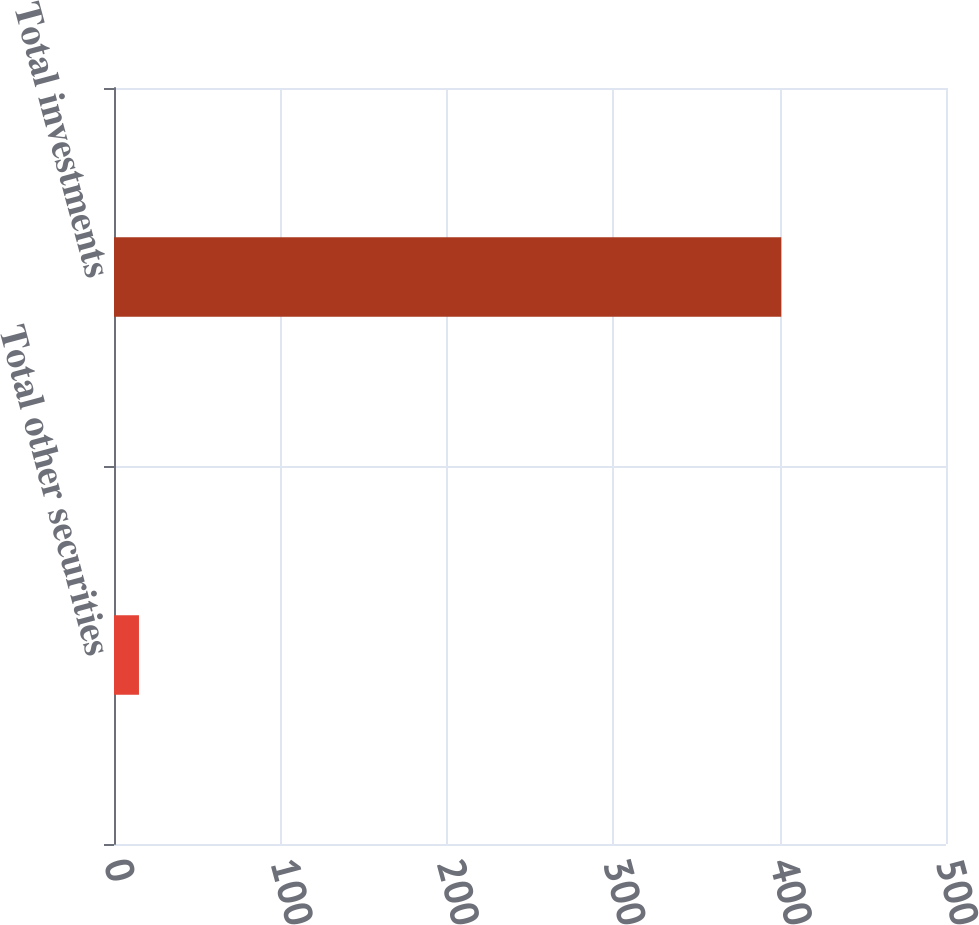Convert chart. <chart><loc_0><loc_0><loc_500><loc_500><bar_chart><fcel>Total other securities<fcel>Total investments<nl><fcel>15<fcel>401<nl></chart> 